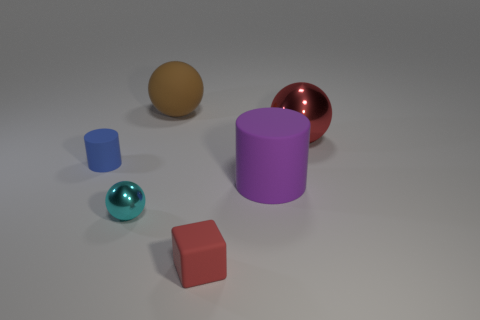How many purple objects are made of the same material as the large brown thing?
Your answer should be compact. 1. There is a metal sphere that is on the left side of the shiny sphere right of the big cylinder; are there any purple rubber things left of it?
Your answer should be very brief. No. How many blocks are small brown matte things or tiny red rubber objects?
Ensure brevity in your answer.  1. Does the large red shiny object have the same shape as the tiny matte thing right of the tiny cyan metal sphere?
Your answer should be compact. No. Are there fewer red things that are to the right of the big metal thing than tiny cyan spheres?
Keep it short and to the point. Yes. There is a tiny red object; are there any red blocks on the right side of it?
Your response must be concise. No. Is there another tiny rubber thing of the same shape as the tiny blue thing?
Keep it short and to the point. No. There is a rubber object that is the same size as the brown matte ball; what shape is it?
Offer a very short reply. Cylinder. What number of objects are red things that are behind the cube or red metallic things?
Your answer should be very brief. 1. Do the block and the small ball have the same color?
Your answer should be very brief. No. 